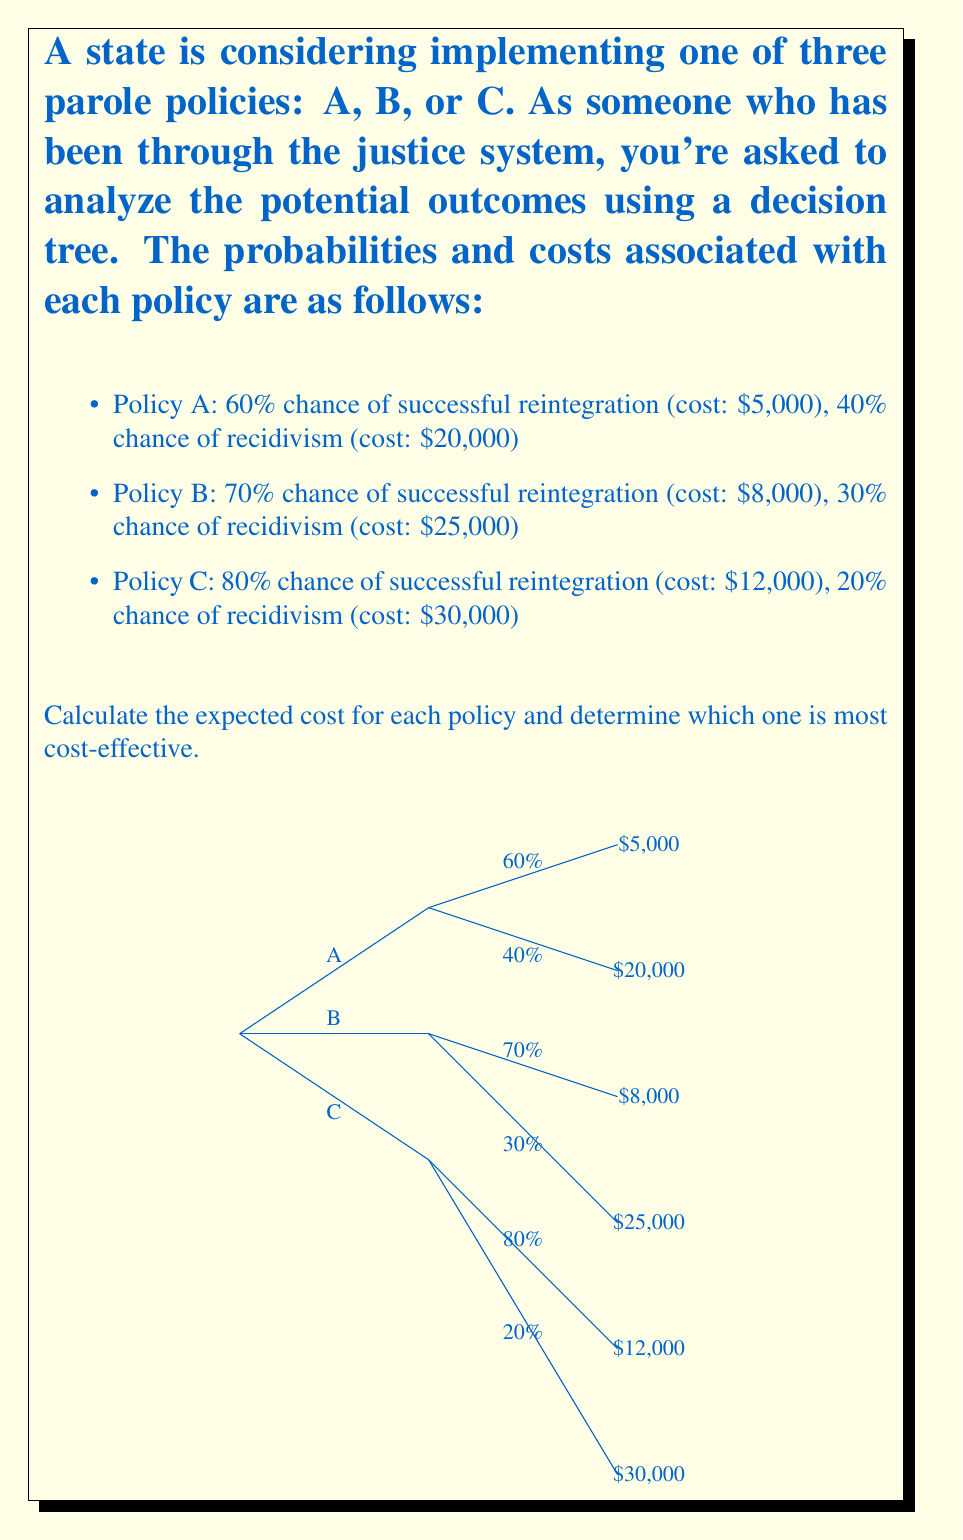Show me your answer to this math problem. Let's calculate the expected cost for each policy:

1. Policy A:
   $$E(A) = 0.60 \times $5,000 + 0.40 \times $20,000$$
   $$E(A) = $3,000 + $8,000 = $11,000$$

2. Policy B:
   $$E(B) = 0.70 \times $8,000 + 0.30 \times $25,000$$
   $$E(B) = $5,600 + $7,500 = $13,100$$

3. Policy C:
   $$E(C) = 0.80 \times $12,000 + 0.20 \times $30,000$$
   $$E(C) = $9,600 + $6,000 = $15,600$$

To determine the most cost-effective policy, we compare the expected costs:

Policy A: $11,000
Policy B: $13,100
Policy C: $15,600

Policy A has the lowest expected cost, making it the most cost-effective option.
Answer: Policy A, with an expected cost of $11,000. 